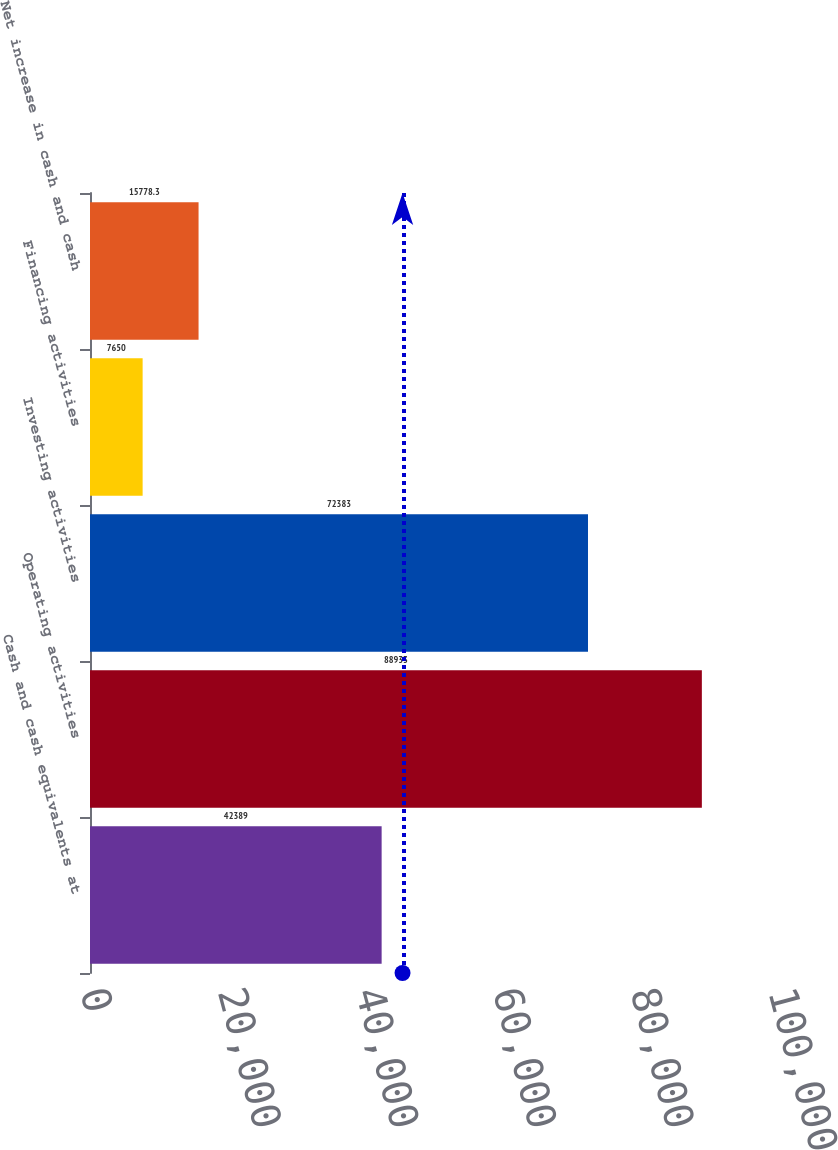Convert chart to OTSL. <chart><loc_0><loc_0><loc_500><loc_500><bar_chart><fcel>Cash and cash equivalents at<fcel>Operating activities<fcel>Investing activities<fcel>Financing activities<fcel>Net increase in cash and cash<nl><fcel>42389<fcel>88933<fcel>72383<fcel>7650<fcel>15778.3<nl></chart> 